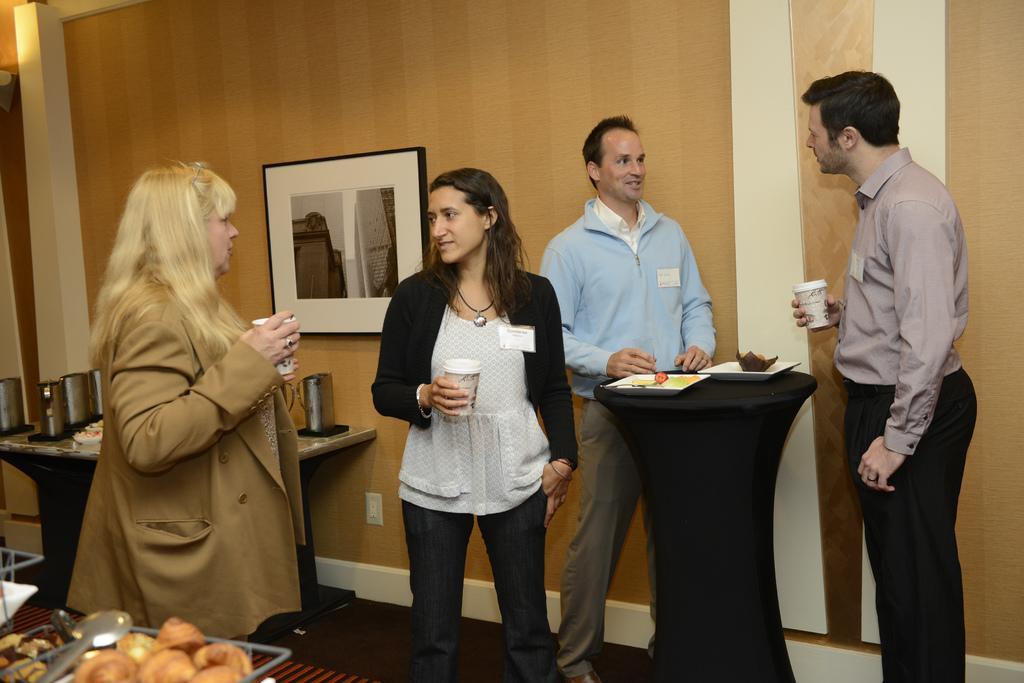Can you describe this image briefly? In this image i can see 2 woman and 2 men standing and holding a cups in their hands. In the background i can see a wall and a photo frame attached to it. 